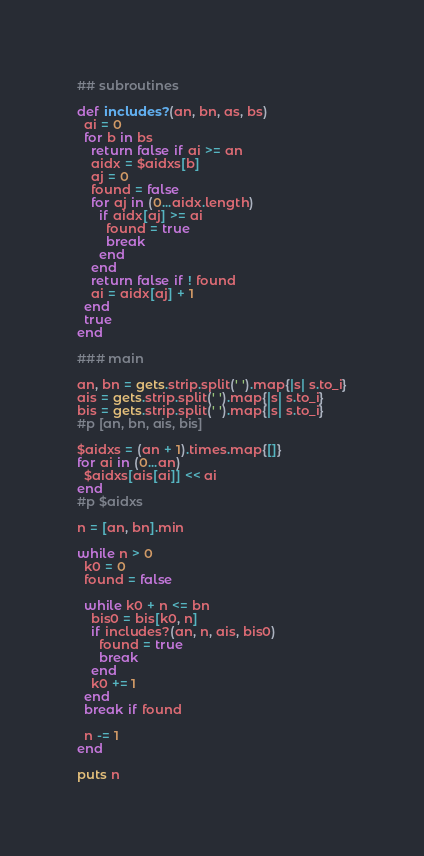<code> <loc_0><loc_0><loc_500><loc_500><_Ruby_>## subroutines

def includes?(an, bn, as, bs)
  ai = 0
  for b in bs
    return false if ai >= an
    aidx = $aidxs[b]
    aj = 0
    found = false
    for aj in (0...aidx.length)
      if aidx[aj] >= ai
        found = true
        break
      end
    end
    return false if ! found
    ai = aidx[aj] + 1
  end
  true
end

### main

an, bn = gets.strip.split(' ').map{|s| s.to_i}
ais = gets.strip.split(' ').map{|s| s.to_i}
bis = gets.strip.split(' ').map{|s| s.to_i}
#p [an, bn, ais, bis]

$aidxs = (an + 1).times.map{[]}
for ai in (0...an)
  $aidxs[ais[ai]] << ai
end
#p $aidxs

n = [an, bn].min

while n > 0
  k0 = 0
  found = false

  while k0 + n <= bn
    bis0 = bis[k0, n]
    if includes?(an, n, ais, bis0)
      found = true
      break
    end
    k0 += 1
  end
  break if found

  n -= 1
end

puts n</code> 